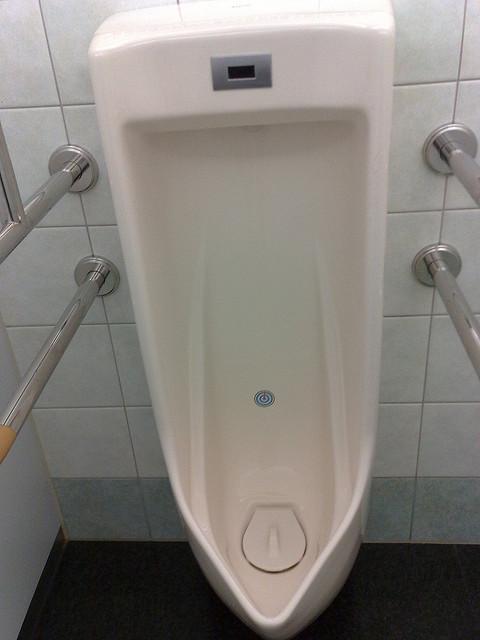How many people are on the field?
Give a very brief answer. 0. 